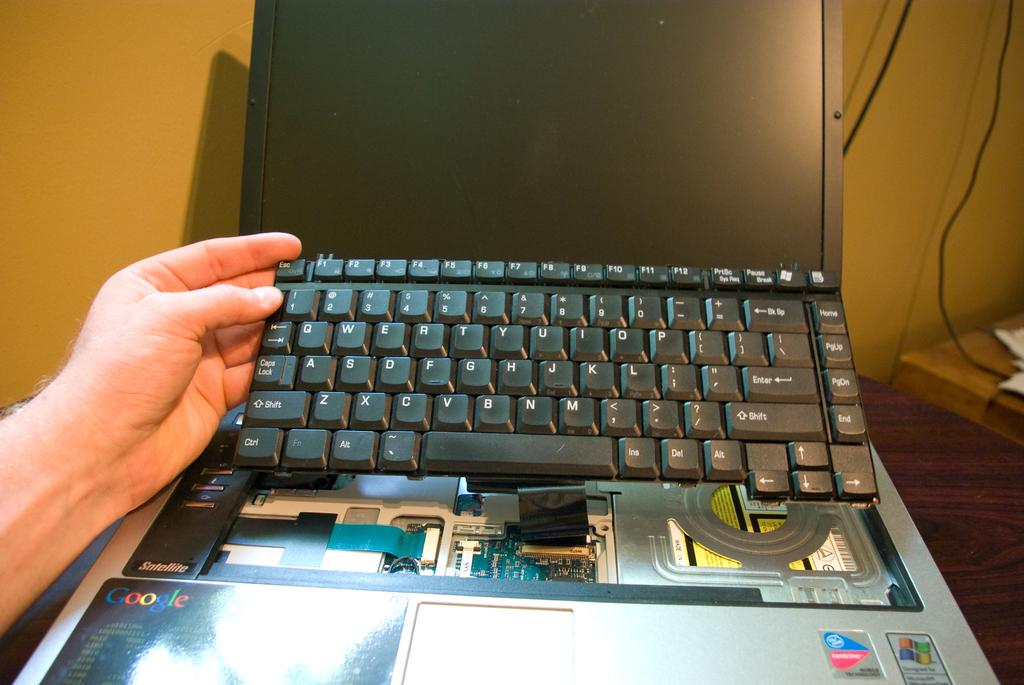<image>
Describe the image concisely. The Google logo can be seen below a laptop computer. 